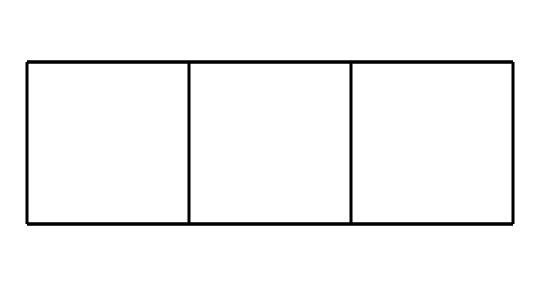What is the chemical name of this compound? The SMILES notation corresponds to a chemical compound with a well-known cage-like structure, which is identified as cubane.
Answer: cubane How many carbon atoms are in the compound? Analyzing the SMILES, there are a total of eight carbon atoms represented in the structure, as indicated by the number of carbon 'C' symbols present.
Answer: eight What is the overall symmetry of cubane? Cubane has a high degree of symmetry; specifically, it exhibits octahedral symmetry due to its cube-like structure.
Answer: octahedral How many hydrogen atoms are associated with cubane? Each carbon in cubane is bonded to two hydrogen atoms, leading to a total of 16 hydrogen atoms, calculated as 8 carbon atoms multiplied by 2.
Answer: sixteen Is cubane a saturated compound? Yes, cubane is saturated because each carbon atom is fully bonded to hydrogen atoms without any double or triple bonds present in its structure.
Answer: yes What is the bond angle between neighboring carbon atoms in cubane? The bond angle between neighboring carbon atoms is approximately 90 degrees, characteristic of its cubic structure.
Answer: ninety degrees What type of strain exists in cubane's structure? Cubane experiences angle strain due to the deviation from the ideal tetrahedral angle of sp3 hybridized carbons, which leads to instability in its geometry.
Answer: angle strain 